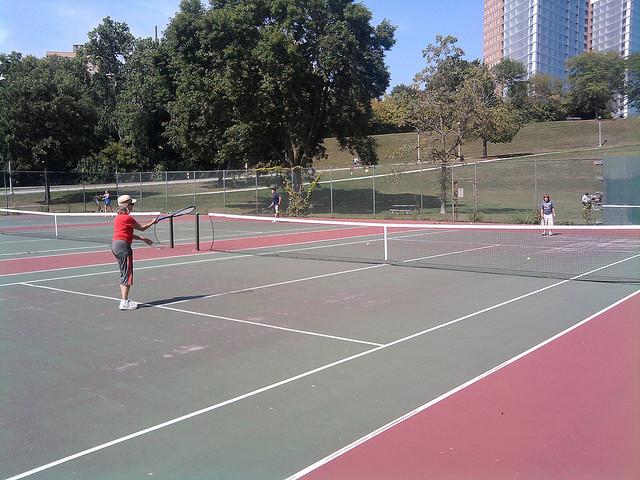Are they playing tennis?
Short answer required. Yes. Which hand is the person on the right holding the racket with?
Short answer required. Right. Is there a house visible in this picture?
Keep it brief. No. Is the park crowded?
Short answer required. No. Is tennis considered a competitive sport?
Answer briefly. Yes. Does the tennis court look freshly painted?
Concise answer only. No. 